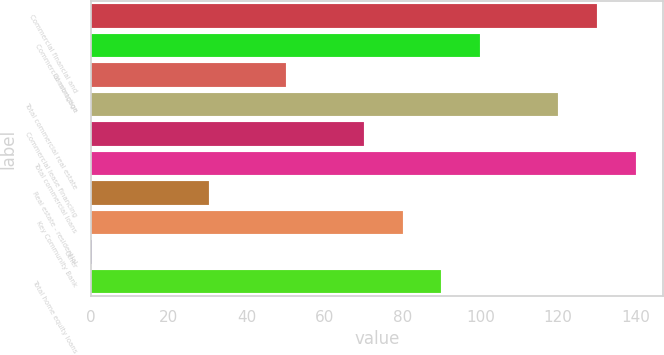<chart> <loc_0><loc_0><loc_500><loc_500><bar_chart><fcel>Commercial financial and<fcel>Commercial mortgage<fcel>Construction<fcel>Total commercial real estate<fcel>Commercial lease financing<fcel>Total commercial loans<fcel>Real estate - residential<fcel>Key Community Bank<fcel>Other<fcel>Total home equity loans<nl><fcel>129.91<fcel>100<fcel>50.15<fcel>119.94<fcel>70.09<fcel>139.88<fcel>30.21<fcel>80.06<fcel>0.3<fcel>90.03<nl></chart> 